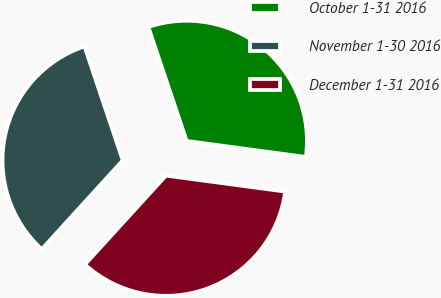Convert chart to OTSL. <chart><loc_0><loc_0><loc_500><loc_500><pie_chart><fcel>October 1-31 2016<fcel>November 1-30 2016<fcel>December 1-31 2016<nl><fcel>32.28%<fcel>33.08%<fcel>34.65%<nl></chart> 